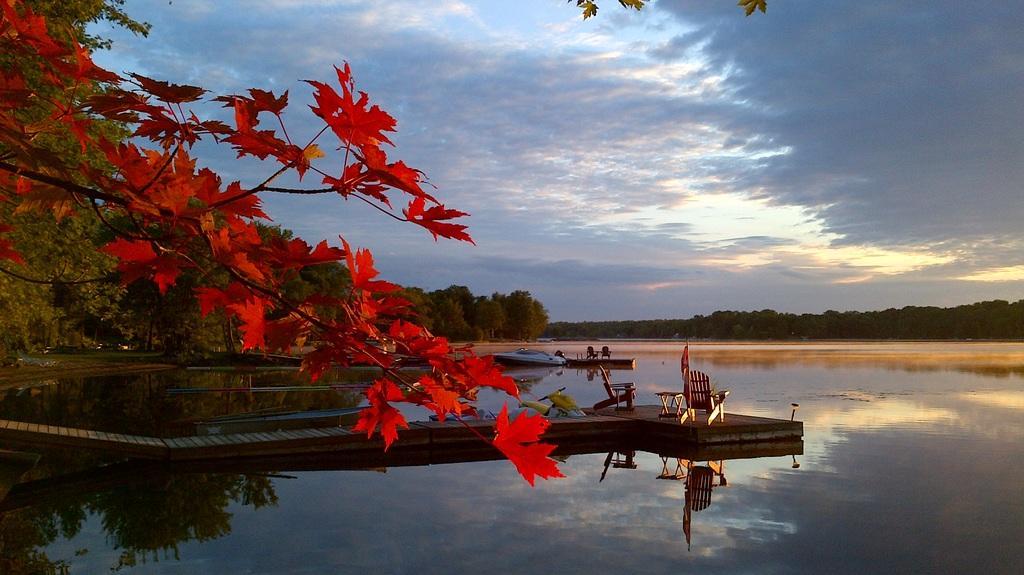Could you give a brief overview of what you see in this image? To the left side of the image there is a stem with red leaves. And to the bottom of the image there is water. And in the middle of the water there is a path with chairs and tables and on it. In the background there are trees. And to the top of the image there is a sky. 